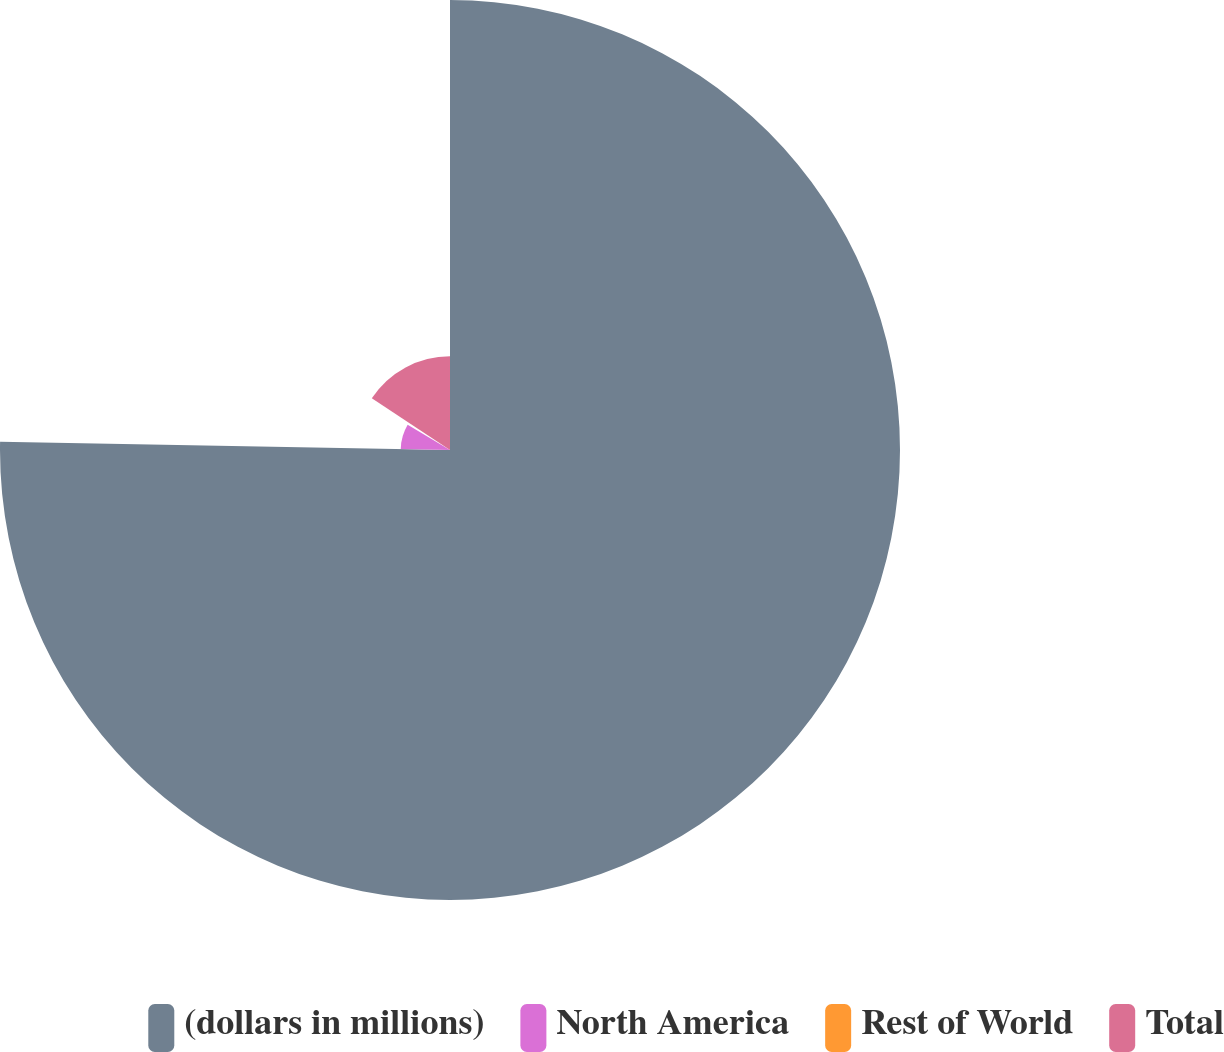Convert chart to OTSL. <chart><loc_0><loc_0><loc_500><loc_500><pie_chart><fcel>(dollars in millions)<fcel>North America<fcel>Rest of World<fcel>Total<nl><fcel>75.29%<fcel>8.24%<fcel>0.78%<fcel>15.69%<nl></chart> 